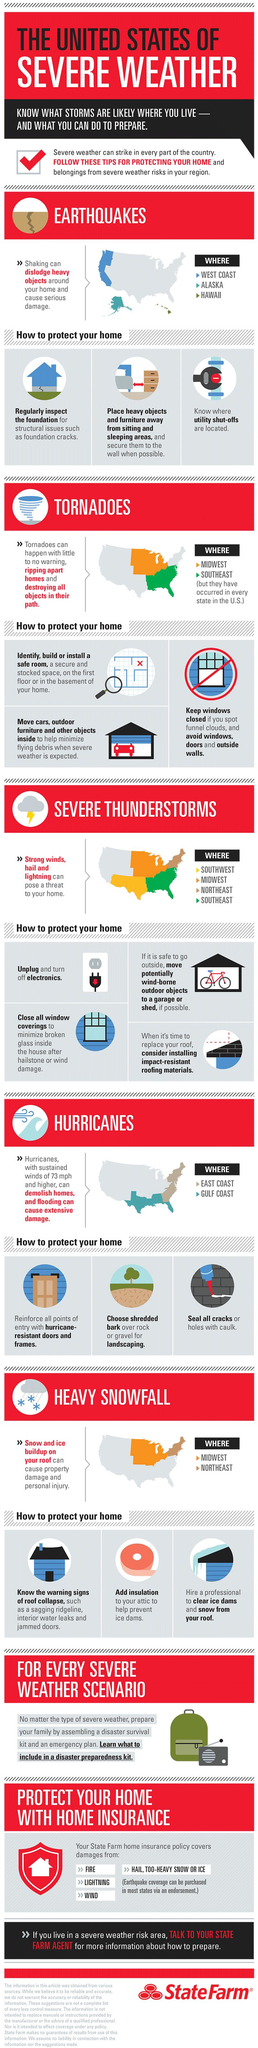Give some essential details in this illustration. The coastal regions of the United States, particularly the East Coast and the Gulf Coast, are susceptible to damage from hurricanes due to their location and geography. Heavy snowfall frequently occurs in the Midwest and Northeast regions of the United States. The states and regions of the United States that are more prone to earthquakes include the West Coast, Alaska, and Hawaii. 